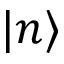<formula> <loc_0><loc_0><loc_500><loc_500>| n \rangle</formula> 